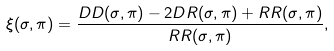<formula> <loc_0><loc_0><loc_500><loc_500>\xi ( \sigma , \pi ) = \frac { D D ( \sigma , \pi ) - 2 D R ( \sigma , \pi ) + R R ( \sigma , \pi ) } { R R ( \sigma , \pi ) } ,</formula> 